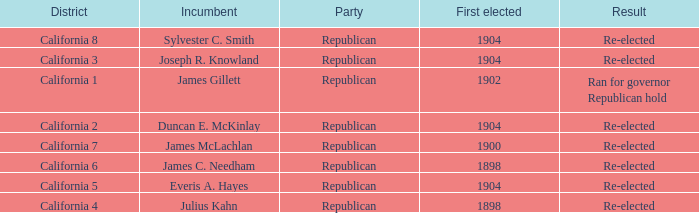Which District has a First Elected of 1904 and an Incumbent of Duncan E. Mckinlay? California 2. 